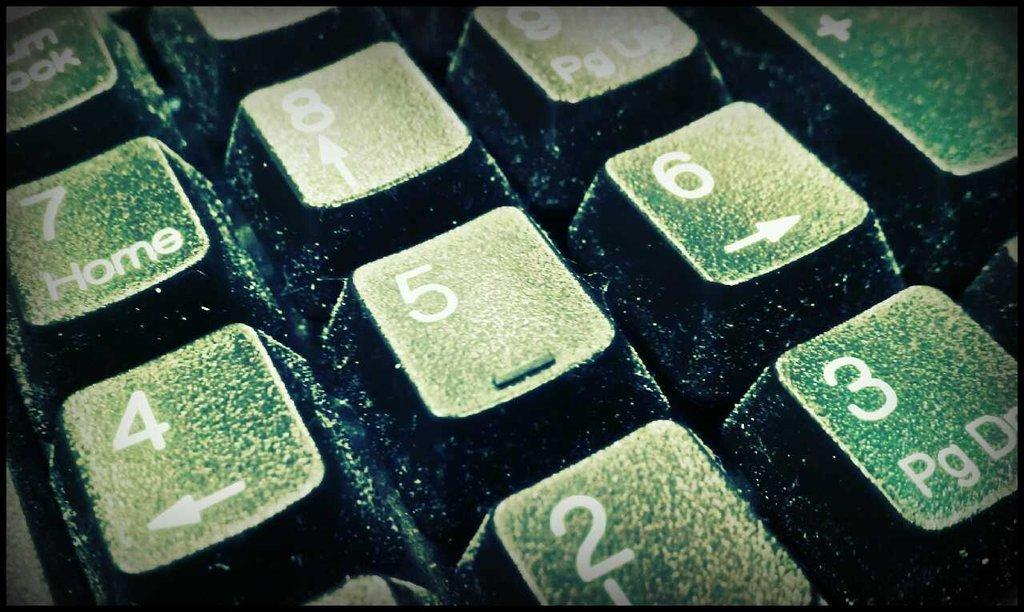<image>
Relay a brief, clear account of the picture shown. Keyboard numpad with the num lock on the top left. 